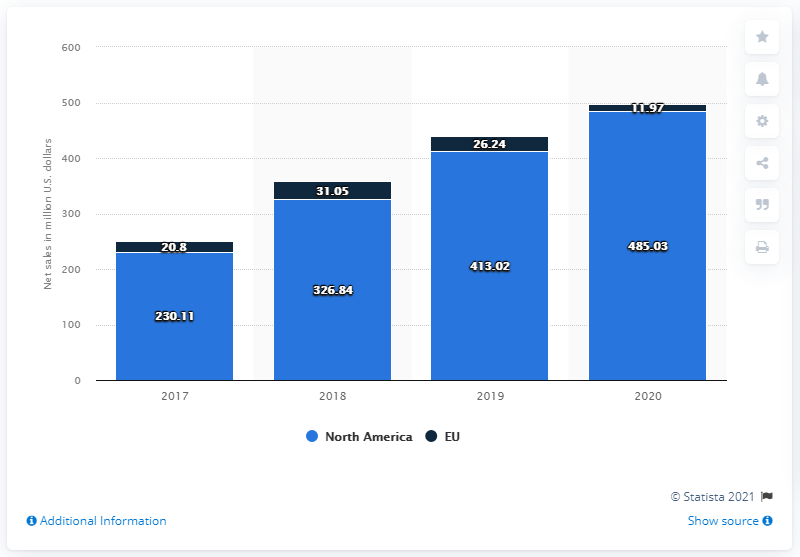List a handful of essential elements in this visual. In 2020, Casper generated $485.03 million in revenue in the United States. 